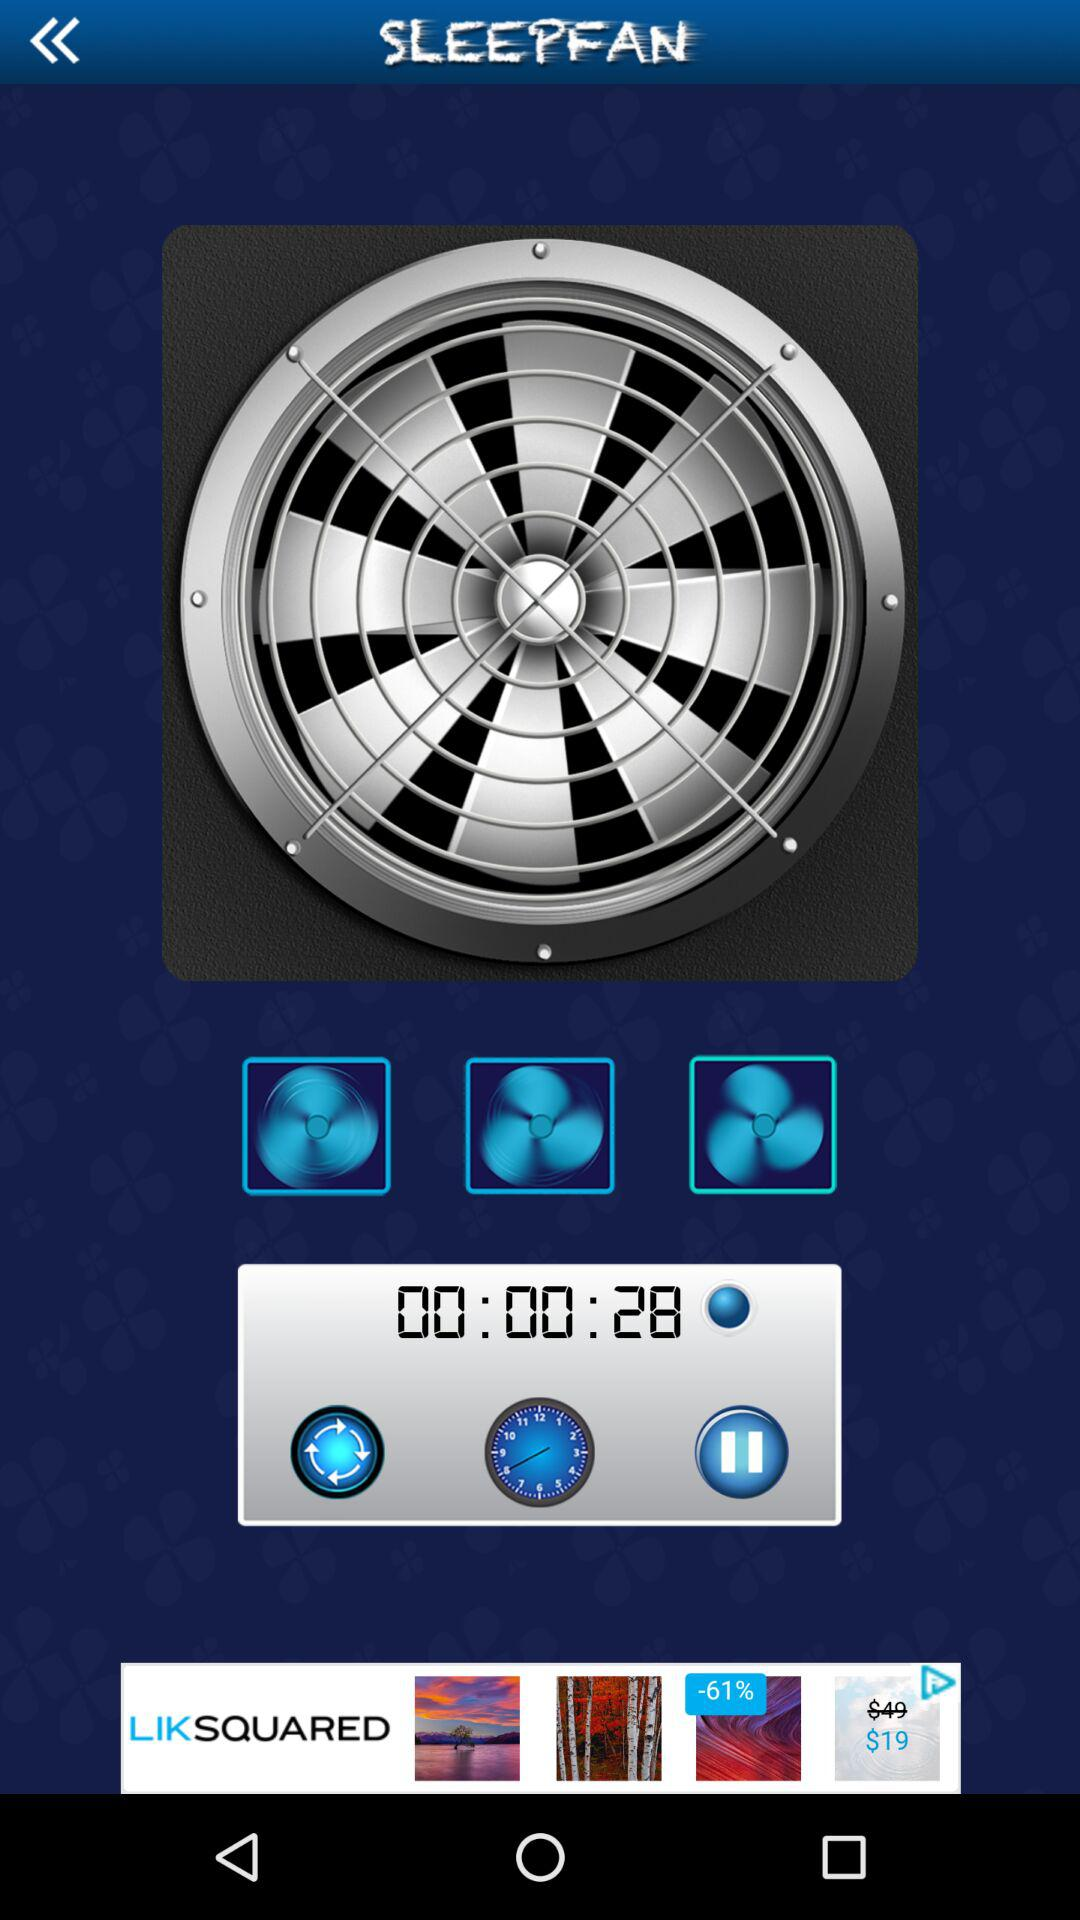What is the duration? The duration is 28 seconds. 